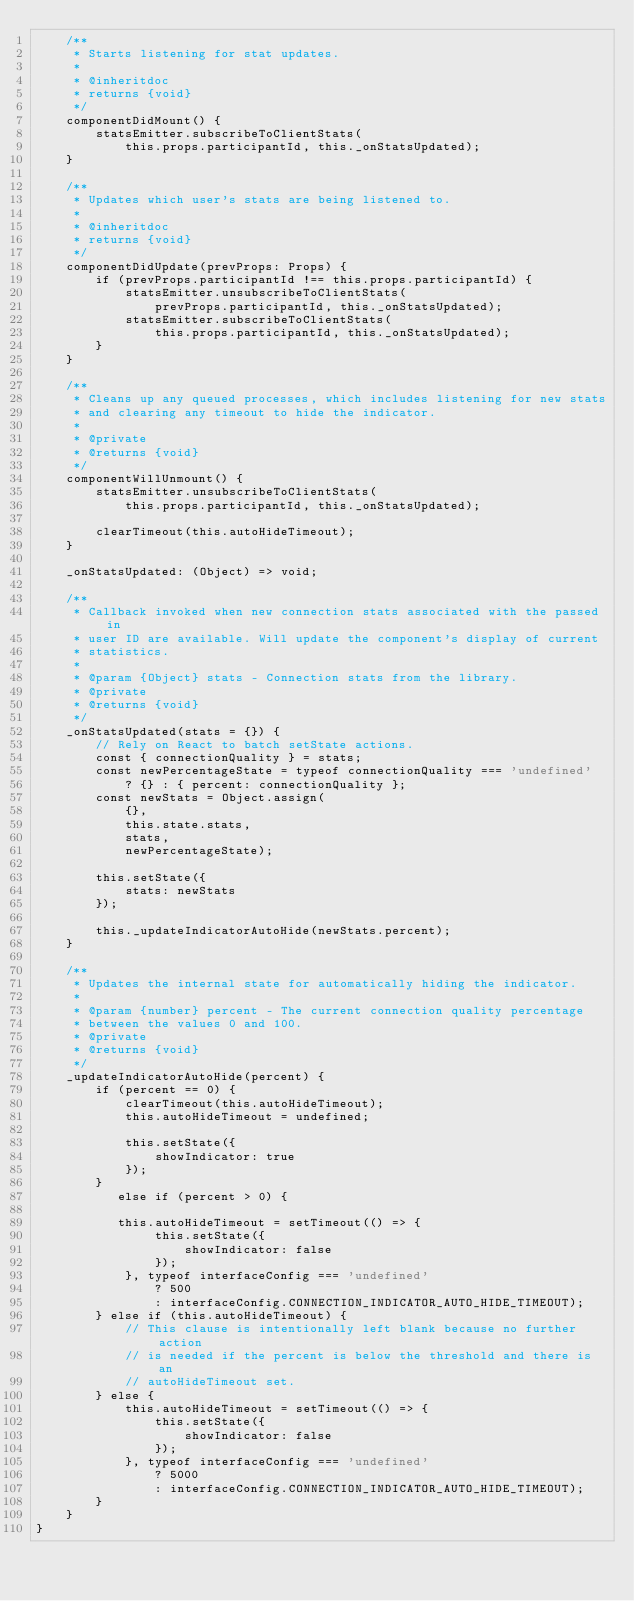<code> <loc_0><loc_0><loc_500><loc_500><_JavaScript_>    /**
     * Starts listening for stat updates.
     *
     * @inheritdoc
     * returns {void}
     */
    componentDidMount() {
        statsEmitter.subscribeToClientStats(
            this.props.participantId, this._onStatsUpdated);
    }

    /**
     * Updates which user's stats are being listened to.
     *
     * @inheritdoc
     * returns {void}
     */
    componentDidUpdate(prevProps: Props) {
        if (prevProps.participantId !== this.props.participantId) {
            statsEmitter.unsubscribeToClientStats(
                prevProps.participantId, this._onStatsUpdated);
            statsEmitter.subscribeToClientStats(
                this.props.participantId, this._onStatsUpdated);
        }
    }

    /**
     * Cleans up any queued processes, which includes listening for new stats
     * and clearing any timeout to hide the indicator.
     *
     * @private
     * @returns {void}
     */
    componentWillUnmount() {
        statsEmitter.unsubscribeToClientStats(
            this.props.participantId, this._onStatsUpdated);

        clearTimeout(this.autoHideTimeout);
    }

    _onStatsUpdated: (Object) => void;

    /**
     * Callback invoked when new connection stats associated with the passed in
     * user ID are available. Will update the component's display of current
     * statistics.
     *
     * @param {Object} stats - Connection stats from the library.
     * @private
     * @returns {void}
     */
    _onStatsUpdated(stats = {}) {
        // Rely on React to batch setState actions.
        const { connectionQuality } = stats;
        const newPercentageState = typeof connectionQuality === 'undefined'
            ? {} : { percent: connectionQuality };
        const newStats = Object.assign(
            {},
            this.state.stats,
            stats,
            newPercentageState);

        this.setState({
            stats: newStats
        });

        this._updateIndicatorAutoHide(newStats.percent);
    }

    /**
     * Updates the internal state for automatically hiding the indicator.
     *
     * @param {number} percent - The current connection quality percentage
     * between the values 0 and 100.
     * @private
     * @returns {void}
     */
    _updateIndicatorAutoHide(percent) {
        if (percent == 0) {
            clearTimeout(this.autoHideTimeout);
            this.autoHideTimeout = undefined;

            this.setState({
                showIndicator: true
            });
        }
           else if (percent > 0) {
           
           this.autoHideTimeout = setTimeout(() => {
                this.setState({
                    showIndicator: false
                });
            }, typeof interfaceConfig === 'undefined'
                ? 500
                : interfaceConfig.CONNECTION_INDICATOR_AUTO_HIDE_TIMEOUT);
        } else if (this.autoHideTimeout) {
            // This clause is intentionally left blank because no further action
            // is needed if the percent is below the threshold and there is an
            // autoHideTimeout set.
        } else {
            this.autoHideTimeout = setTimeout(() => {
                this.setState({
                    showIndicator: false
                });
            }, typeof interfaceConfig === 'undefined'
                ? 5000
                : interfaceConfig.CONNECTION_INDICATOR_AUTO_HIDE_TIMEOUT);
        }
    }
}
</code> 